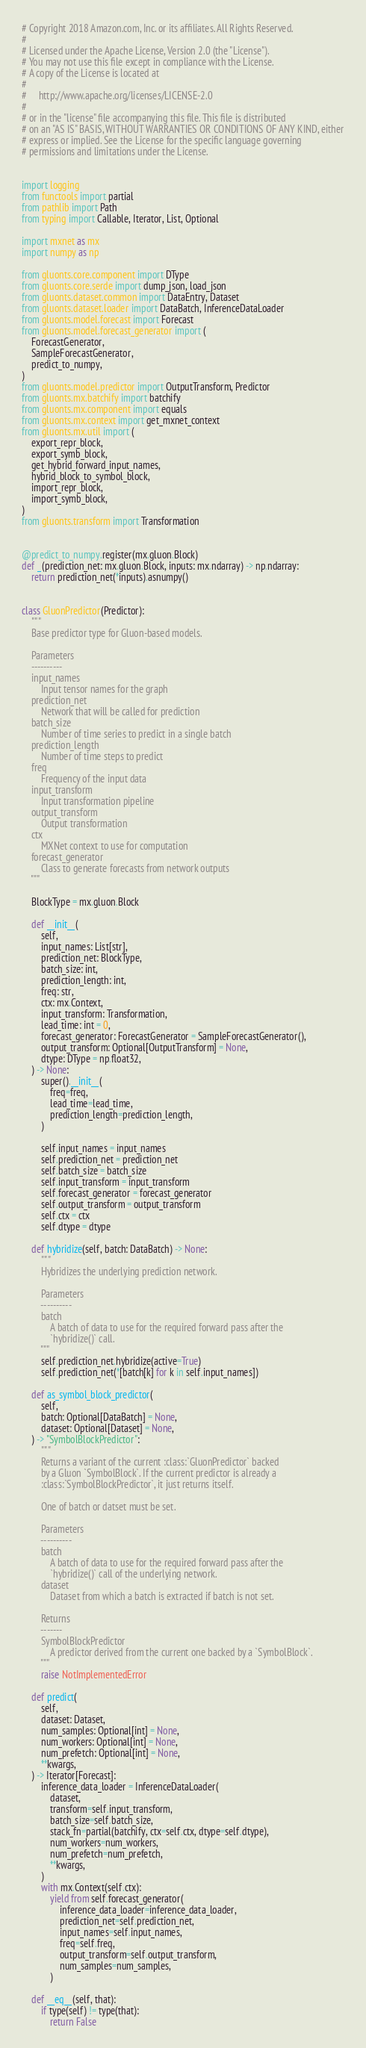<code> <loc_0><loc_0><loc_500><loc_500><_Python_># Copyright 2018 Amazon.com, Inc. or its affiliates. All Rights Reserved.
#
# Licensed under the Apache License, Version 2.0 (the "License").
# You may not use this file except in compliance with the License.
# A copy of the License is located at
#
#     http://www.apache.org/licenses/LICENSE-2.0
#
# or in the "license" file accompanying this file. This file is distributed
# on an "AS IS" BASIS, WITHOUT WARRANTIES OR CONDITIONS OF ANY KIND, either
# express or implied. See the License for the specific language governing
# permissions and limitations under the License.


import logging
from functools import partial
from pathlib import Path
from typing import Callable, Iterator, List, Optional

import mxnet as mx
import numpy as np

from gluonts.core.component import DType
from gluonts.core.serde import dump_json, load_json
from gluonts.dataset.common import DataEntry, Dataset
from gluonts.dataset.loader import DataBatch, InferenceDataLoader
from gluonts.model.forecast import Forecast
from gluonts.model.forecast_generator import (
    ForecastGenerator,
    SampleForecastGenerator,
    predict_to_numpy,
)
from gluonts.model.predictor import OutputTransform, Predictor
from gluonts.mx.batchify import batchify
from gluonts.mx.component import equals
from gluonts.mx.context import get_mxnet_context
from gluonts.mx.util import (
    export_repr_block,
    export_symb_block,
    get_hybrid_forward_input_names,
    hybrid_block_to_symbol_block,
    import_repr_block,
    import_symb_block,
)
from gluonts.transform import Transformation


@predict_to_numpy.register(mx.gluon.Block)
def _(prediction_net: mx.gluon.Block, inputs: mx.ndarray) -> np.ndarray:
    return prediction_net(*inputs).asnumpy()


class GluonPredictor(Predictor):
    """
    Base predictor type for Gluon-based models.

    Parameters
    ----------
    input_names
        Input tensor names for the graph
    prediction_net
        Network that will be called for prediction
    batch_size
        Number of time series to predict in a single batch
    prediction_length
        Number of time steps to predict
    freq
        Frequency of the input data
    input_transform
        Input transformation pipeline
    output_transform
        Output transformation
    ctx
        MXNet context to use for computation
    forecast_generator
        Class to generate forecasts from network outputs
    """

    BlockType = mx.gluon.Block

    def __init__(
        self,
        input_names: List[str],
        prediction_net: BlockType,
        batch_size: int,
        prediction_length: int,
        freq: str,
        ctx: mx.Context,
        input_transform: Transformation,
        lead_time: int = 0,
        forecast_generator: ForecastGenerator = SampleForecastGenerator(),
        output_transform: Optional[OutputTransform] = None,
        dtype: DType = np.float32,
    ) -> None:
        super().__init__(
            freq=freq,
            lead_time=lead_time,
            prediction_length=prediction_length,
        )

        self.input_names = input_names
        self.prediction_net = prediction_net
        self.batch_size = batch_size
        self.input_transform = input_transform
        self.forecast_generator = forecast_generator
        self.output_transform = output_transform
        self.ctx = ctx
        self.dtype = dtype

    def hybridize(self, batch: DataBatch) -> None:
        """
        Hybridizes the underlying prediction network.

        Parameters
        ----------
        batch
            A batch of data to use for the required forward pass after the
            `hybridize()` call.
        """
        self.prediction_net.hybridize(active=True)
        self.prediction_net(*[batch[k] for k in self.input_names])

    def as_symbol_block_predictor(
        self,
        batch: Optional[DataBatch] = None,
        dataset: Optional[Dataset] = None,
    ) -> "SymbolBlockPredictor":
        """
        Returns a variant of the current :class:`GluonPredictor` backed
        by a Gluon `SymbolBlock`. If the current predictor is already a
        :class:`SymbolBlockPredictor`, it just returns itself.

        One of batch or datset must be set.

        Parameters
        ----------
        batch
            A batch of data to use for the required forward pass after the
            `hybridize()` call of the underlying network.
        dataset
            Dataset from which a batch is extracted if batch is not set.

        Returns
        -------
        SymbolBlockPredictor
            A predictor derived from the current one backed by a `SymbolBlock`.
        """
        raise NotImplementedError

    def predict(
        self,
        dataset: Dataset,
        num_samples: Optional[int] = None,
        num_workers: Optional[int] = None,
        num_prefetch: Optional[int] = None,
        **kwargs,
    ) -> Iterator[Forecast]:
        inference_data_loader = InferenceDataLoader(
            dataset,
            transform=self.input_transform,
            batch_size=self.batch_size,
            stack_fn=partial(batchify, ctx=self.ctx, dtype=self.dtype),
            num_workers=num_workers,
            num_prefetch=num_prefetch,
            **kwargs,
        )
        with mx.Context(self.ctx):
            yield from self.forecast_generator(
                inference_data_loader=inference_data_loader,
                prediction_net=self.prediction_net,
                input_names=self.input_names,
                freq=self.freq,
                output_transform=self.output_transform,
                num_samples=num_samples,
            )

    def __eq__(self, that):
        if type(self) != type(that):
            return False
</code> 